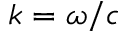<formula> <loc_0><loc_0><loc_500><loc_500>k = \omega / c</formula> 